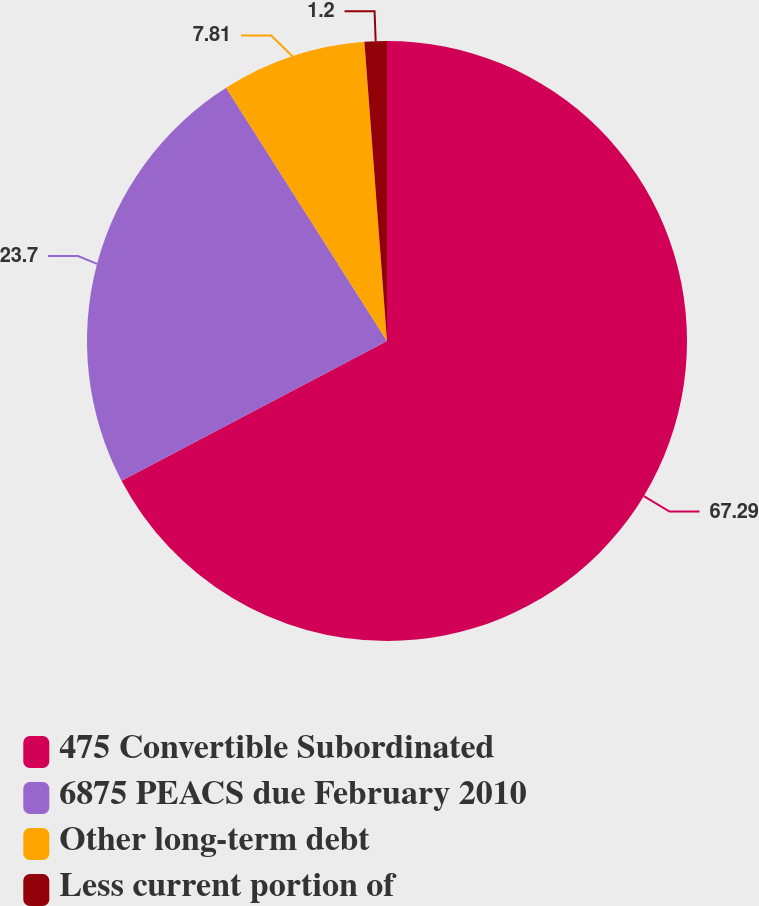<chart> <loc_0><loc_0><loc_500><loc_500><pie_chart><fcel>475 Convertible Subordinated<fcel>6875 PEACS due February 2010<fcel>Other long-term debt<fcel>Less current portion of<nl><fcel>67.29%<fcel>23.7%<fcel>7.81%<fcel>1.2%<nl></chart> 